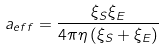<formula> <loc_0><loc_0><loc_500><loc_500>a _ { e f f } = \frac { \xi _ { S } \xi _ { E } } { 4 \pi \eta \left ( \xi _ { S } + \xi _ { E } \right ) }</formula> 